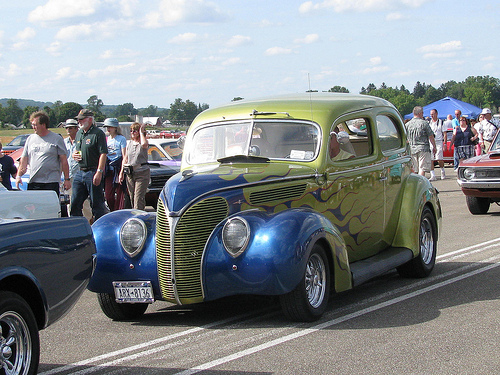<image>
Is the woman in the car? No. The woman is not contained within the car. These objects have a different spatial relationship. Is there a man above the car? No. The man is not positioned above the car. The vertical arrangement shows a different relationship. 